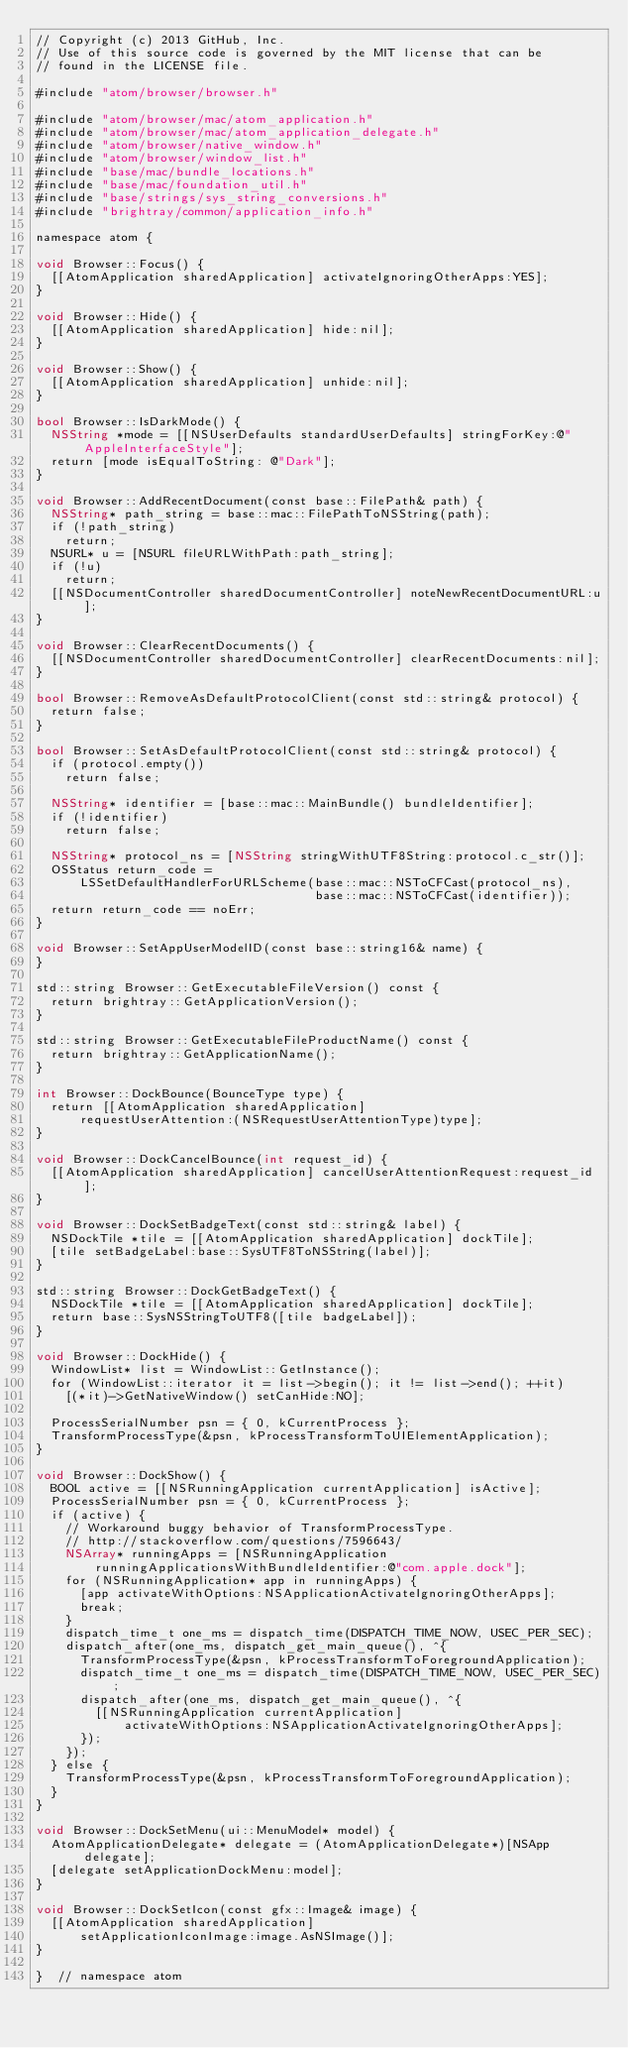Convert code to text. <code><loc_0><loc_0><loc_500><loc_500><_ObjectiveC_>// Copyright (c) 2013 GitHub, Inc.
// Use of this source code is governed by the MIT license that can be
// found in the LICENSE file.

#include "atom/browser/browser.h"

#include "atom/browser/mac/atom_application.h"
#include "atom/browser/mac/atom_application_delegate.h"
#include "atom/browser/native_window.h"
#include "atom/browser/window_list.h"
#include "base/mac/bundle_locations.h"
#include "base/mac/foundation_util.h"
#include "base/strings/sys_string_conversions.h"
#include "brightray/common/application_info.h"

namespace atom {

void Browser::Focus() {
  [[AtomApplication sharedApplication] activateIgnoringOtherApps:YES];
}

void Browser::Hide() {
  [[AtomApplication sharedApplication] hide:nil];
}

void Browser::Show() {
  [[AtomApplication sharedApplication] unhide:nil];
}

bool Browser::IsDarkMode() {
  NSString *mode = [[NSUserDefaults standardUserDefaults] stringForKey:@"AppleInterfaceStyle"];
  return [mode isEqualToString: @"Dark"];
}

void Browser::AddRecentDocument(const base::FilePath& path) {
  NSString* path_string = base::mac::FilePathToNSString(path);
  if (!path_string)
    return;
  NSURL* u = [NSURL fileURLWithPath:path_string];
  if (!u)
    return;
  [[NSDocumentController sharedDocumentController] noteNewRecentDocumentURL:u];
}

void Browser::ClearRecentDocuments() {
  [[NSDocumentController sharedDocumentController] clearRecentDocuments:nil];
}

bool Browser::RemoveAsDefaultProtocolClient(const std::string& protocol) {
  return false;
}

bool Browser::SetAsDefaultProtocolClient(const std::string& protocol) {
  if (protocol.empty())
    return false;

  NSString* identifier = [base::mac::MainBundle() bundleIdentifier];
  if (!identifier)
    return false;

  NSString* protocol_ns = [NSString stringWithUTF8String:protocol.c_str()];
  OSStatus return_code =
      LSSetDefaultHandlerForURLScheme(base::mac::NSToCFCast(protocol_ns),
                                      base::mac::NSToCFCast(identifier));
  return return_code == noErr;
}

void Browser::SetAppUserModelID(const base::string16& name) {
}

std::string Browser::GetExecutableFileVersion() const {
  return brightray::GetApplicationVersion();
}

std::string Browser::GetExecutableFileProductName() const {
  return brightray::GetApplicationName();
}

int Browser::DockBounce(BounceType type) {
  return [[AtomApplication sharedApplication]
      requestUserAttention:(NSRequestUserAttentionType)type];
}

void Browser::DockCancelBounce(int request_id) {
  [[AtomApplication sharedApplication] cancelUserAttentionRequest:request_id];
}

void Browser::DockSetBadgeText(const std::string& label) {
  NSDockTile *tile = [[AtomApplication sharedApplication] dockTile];
  [tile setBadgeLabel:base::SysUTF8ToNSString(label)];
}

std::string Browser::DockGetBadgeText() {
  NSDockTile *tile = [[AtomApplication sharedApplication] dockTile];
  return base::SysNSStringToUTF8([tile badgeLabel]);
}

void Browser::DockHide() {
  WindowList* list = WindowList::GetInstance();
  for (WindowList::iterator it = list->begin(); it != list->end(); ++it)
    [(*it)->GetNativeWindow() setCanHide:NO];

  ProcessSerialNumber psn = { 0, kCurrentProcess };
  TransformProcessType(&psn, kProcessTransformToUIElementApplication);
}

void Browser::DockShow() {
  BOOL active = [[NSRunningApplication currentApplication] isActive];
  ProcessSerialNumber psn = { 0, kCurrentProcess };
  if (active) {
    // Workaround buggy behavior of TransformProcessType.
    // http://stackoverflow.com/questions/7596643/
    NSArray* runningApps = [NSRunningApplication
        runningApplicationsWithBundleIdentifier:@"com.apple.dock"];
    for (NSRunningApplication* app in runningApps) {
      [app activateWithOptions:NSApplicationActivateIgnoringOtherApps];
      break;
    }
    dispatch_time_t one_ms = dispatch_time(DISPATCH_TIME_NOW, USEC_PER_SEC);
    dispatch_after(one_ms, dispatch_get_main_queue(), ^{
      TransformProcessType(&psn, kProcessTransformToForegroundApplication);
      dispatch_time_t one_ms = dispatch_time(DISPATCH_TIME_NOW, USEC_PER_SEC);
      dispatch_after(one_ms, dispatch_get_main_queue(), ^{
        [[NSRunningApplication currentApplication]
            activateWithOptions:NSApplicationActivateIgnoringOtherApps];
      });
    });
  } else {
    TransformProcessType(&psn, kProcessTransformToForegroundApplication);
  }
}

void Browser::DockSetMenu(ui::MenuModel* model) {
  AtomApplicationDelegate* delegate = (AtomApplicationDelegate*)[NSApp delegate];
  [delegate setApplicationDockMenu:model];
}

void Browser::DockSetIcon(const gfx::Image& image) {
  [[AtomApplication sharedApplication]
      setApplicationIconImage:image.AsNSImage()];
}

}  // namespace atom
</code> 